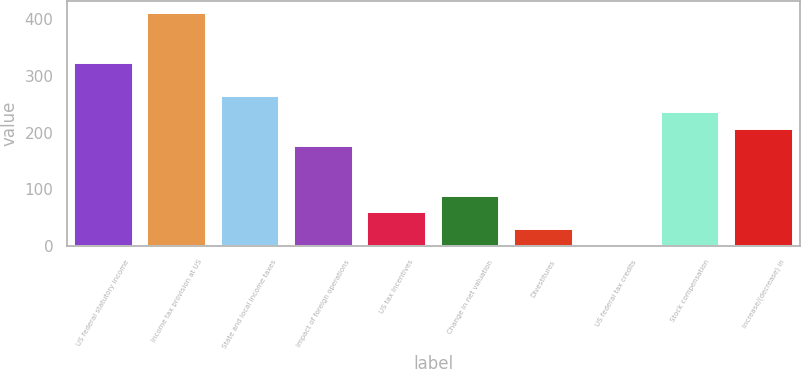Convert chart to OTSL. <chart><loc_0><loc_0><loc_500><loc_500><bar_chart><fcel>US federal statutory income<fcel>Income tax provision at US<fcel>State and local income taxes<fcel>Impact of foreign operations<fcel>US tax incentives<fcel>Change in net valuation<fcel>Divestitures<fcel>US federal tax credits<fcel>Stock compensation<fcel>Increase/(decrease) in<nl><fcel>323.69<fcel>411.86<fcel>264.91<fcel>176.74<fcel>59.18<fcel>88.57<fcel>29.79<fcel>0.4<fcel>235.52<fcel>206.13<nl></chart> 